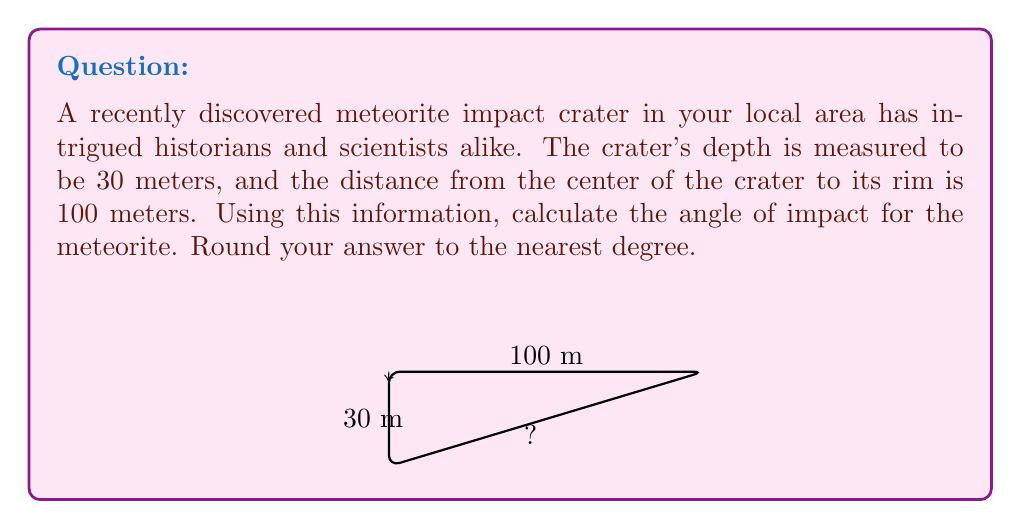Show me your answer to this math problem. To solve this problem, we'll use trigonometry, specifically the tangent function. Let's approach this step-by-step:

1) First, let's visualize the problem. The crater forms a right triangle, where:
   - The depth of the crater (30 meters) is the opposite side
   - The distance from the center to the rim (100 meters) is the adjacent side
   - The angle of impact is the angle we're trying to find

2) In a right triangle, tangent of an angle is the ratio of the opposite side to the adjacent side:

   $$\tan(\theta) = \frac{\text{opposite}}{\text{adjacent}}$$

3) Plugging in our values:

   $$\tan(\theta) = \frac{30}{100} = 0.3$$

4) To find the angle, we need to use the inverse tangent (arctangent) function:

   $$\theta = \arctan(0.3)$$

5) Using a calculator or trigonometric tables:

   $$\theta \approx 16.7^\circ$$

6) Rounding to the nearest degree:

   $$\theta \approx 17^\circ$$

Therefore, the angle of impact for the meteorite was approximately 17 degrees.
Answer: $17^\circ$ 